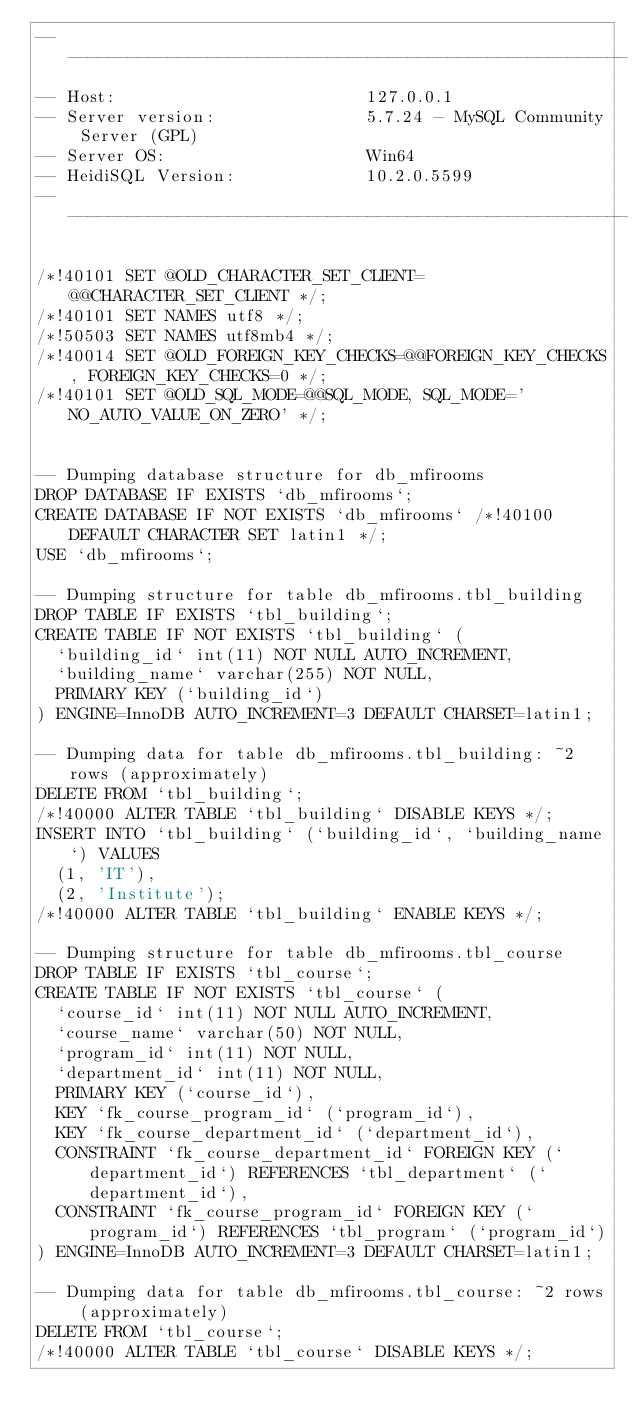Convert code to text. <code><loc_0><loc_0><loc_500><loc_500><_SQL_>-- --------------------------------------------------------
-- Host:                         127.0.0.1
-- Server version:               5.7.24 - MySQL Community Server (GPL)
-- Server OS:                    Win64
-- HeidiSQL Version:             10.2.0.5599
-- --------------------------------------------------------

/*!40101 SET @OLD_CHARACTER_SET_CLIENT=@@CHARACTER_SET_CLIENT */;
/*!40101 SET NAMES utf8 */;
/*!50503 SET NAMES utf8mb4 */;
/*!40014 SET @OLD_FOREIGN_KEY_CHECKS=@@FOREIGN_KEY_CHECKS, FOREIGN_KEY_CHECKS=0 */;
/*!40101 SET @OLD_SQL_MODE=@@SQL_MODE, SQL_MODE='NO_AUTO_VALUE_ON_ZERO' */;


-- Dumping database structure for db_mfirooms
DROP DATABASE IF EXISTS `db_mfirooms`;
CREATE DATABASE IF NOT EXISTS `db_mfirooms` /*!40100 DEFAULT CHARACTER SET latin1 */;
USE `db_mfirooms`;

-- Dumping structure for table db_mfirooms.tbl_building
DROP TABLE IF EXISTS `tbl_building`;
CREATE TABLE IF NOT EXISTS `tbl_building` (
  `building_id` int(11) NOT NULL AUTO_INCREMENT,
  `building_name` varchar(255) NOT NULL,
  PRIMARY KEY (`building_id`)
) ENGINE=InnoDB AUTO_INCREMENT=3 DEFAULT CHARSET=latin1;

-- Dumping data for table db_mfirooms.tbl_building: ~2 rows (approximately)
DELETE FROM `tbl_building`;
/*!40000 ALTER TABLE `tbl_building` DISABLE KEYS */;
INSERT INTO `tbl_building` (`building_id`, `building_name`) VALUES
	(1, 'IT'),
	(2, 'Institute');
/*!40000 ALTER TABLE `tbl_building` ENABLE KEYS */;

-- Dumping structure for table db_mfirooms.tbl_course
DROP TABLE IF EXISTS `tbl_course`;
CREATE TABLE IF NOT EXISTS `tbl_course` (
  `course_id` int(11) NOT NULL AUTO_INCREMENT,
  `course_name` varchar(50) NOT NULL,
  `program_id` int(11) NOT NULL,
  `department_id` int(11) NOT NULL,
  PRIMARY KEY (`course_id`),
  KEY `fk_course_program_id` (`program_id`),
  KEY `fk_course_department_id` (`department_id`),
  CONSTRAINT `fk_course_department_id` FOREIGN KEY (`department_id`) REFERENCES `tbl_department` (`department_id`),
  CONSTRAINT `fk_course_program_id` FOREIGN KEY (`program_id`) REFERENCES `tbl_program` (`program_id`)
) ENGINE=InnoDB AUTO_INCREMENT=3 DEFAULT CHARSET=latin1;

-- Dumping data for table db_mfirooms.tbl_course: ~2 rows (approximately)
DELETE FROM `tbl_course`;
/*!40000 ALTER TABLE `tbl_course` DISABLE KEYS */;</code> 